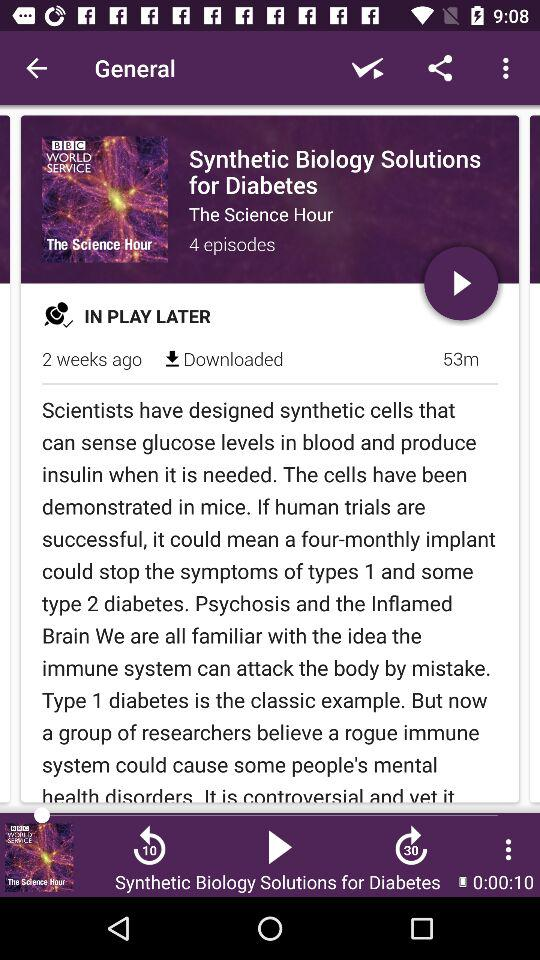How many days ago was the video broadcast? The video was broadcast 2 weeks ago. 